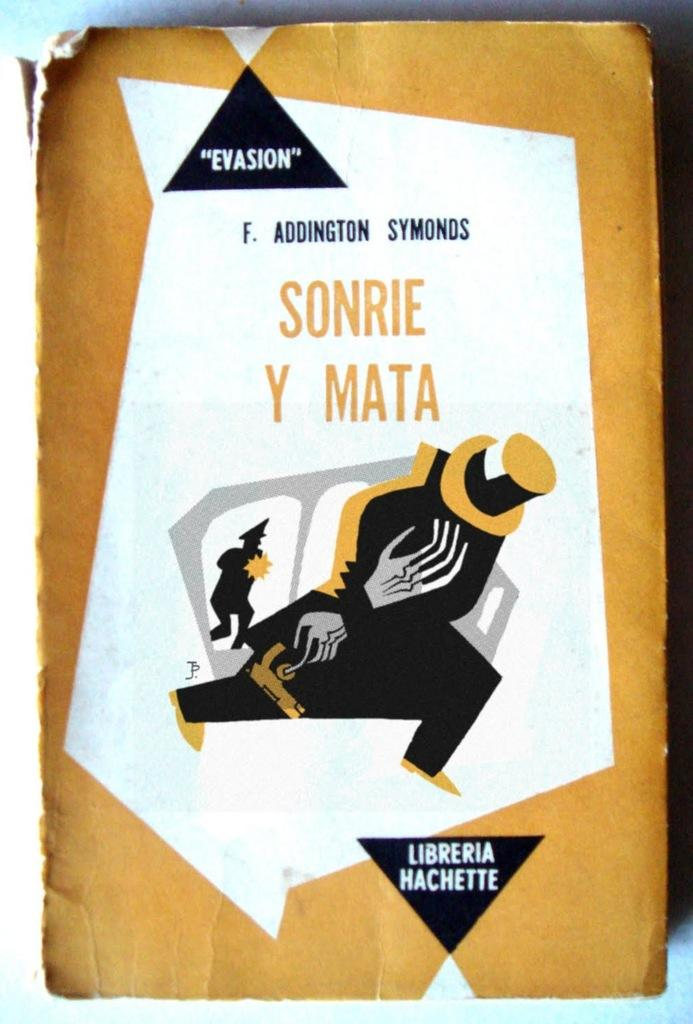<image>
Provide a brief description of the given image. Cover which shows a man in a hat and the words "Sonrie Y Mata" on it. 